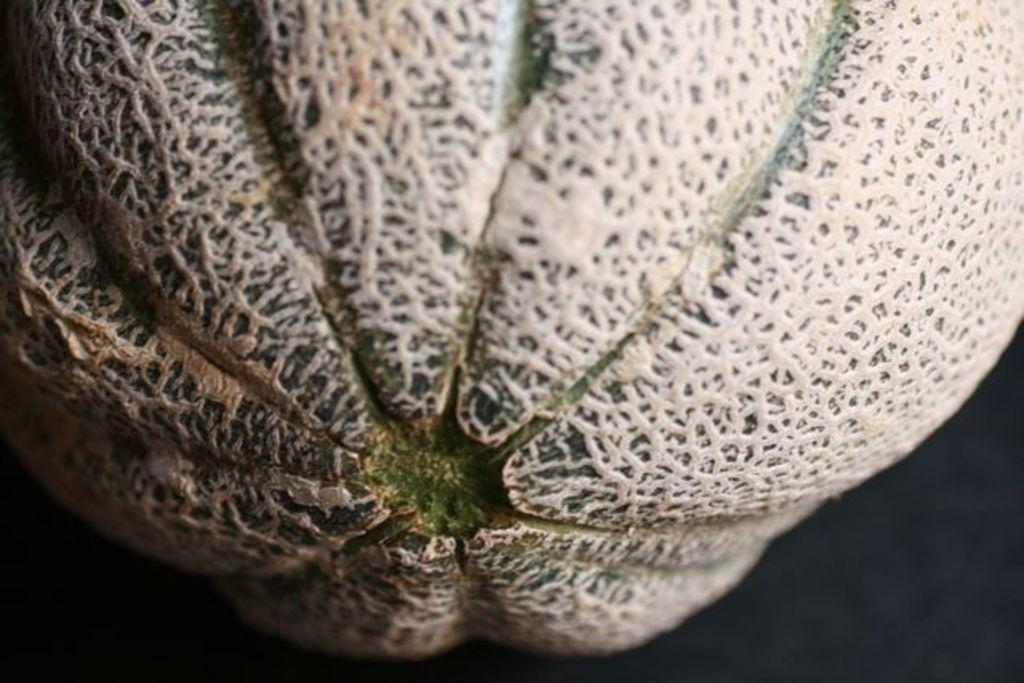What type of food is present in the image? There is a fruit in the image. What is the goose's tendency when it sees the crayon in the image? There is no goose or crayon present in the image, so this question cannot be answered. 